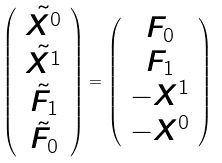<formula> <loc_0><loc_0><loc_500><loc_500>\left ( \begin{array} { c } \tilde { X ^ { 0 } } \\ \tilde { X ^ { 1 } } \\ \tilde { F _ { 1 } } \\ \tilde { F _ { 0 } } \end{array} \right ) = \left ( \begin{array} { c } F _ { 0 } \\ F _ { 1 } \\ - X ^ { 1 } \\ - X ^ { 0 } \end{array} \right )</formula> 